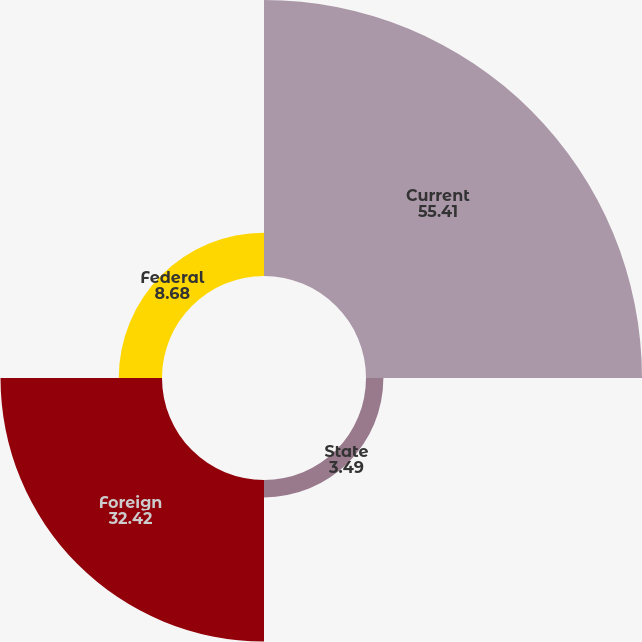Convert chart. <chart><loc_0><loc_0><loc_500><loc_500><pie_chart><fcel>Current<fcel>State<fcel>Foreign<fcel>Federal<nl><fcel>55.41%<fcel>3.49%<fcel>32.42%<fcel>8.68%<nl></chart> 